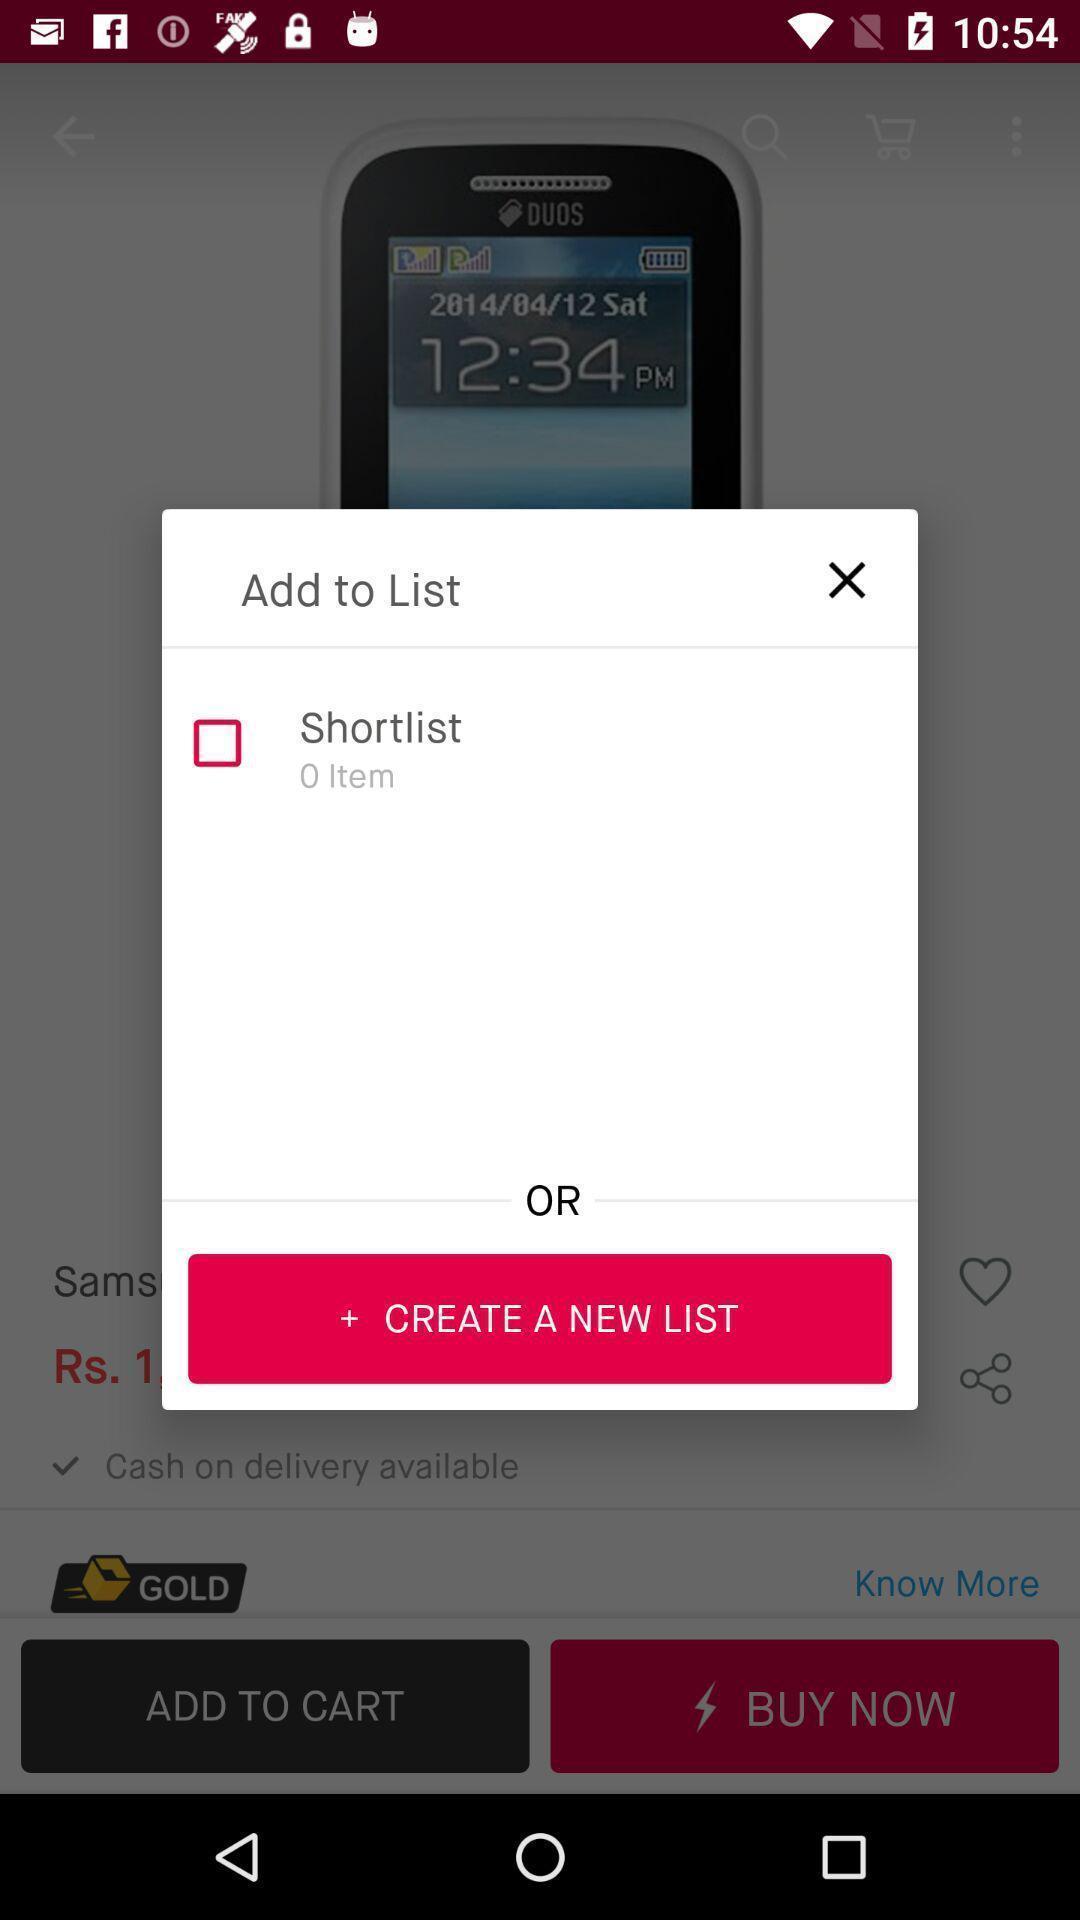Please provide a description for this image. Pop-up to create a new list in app. 